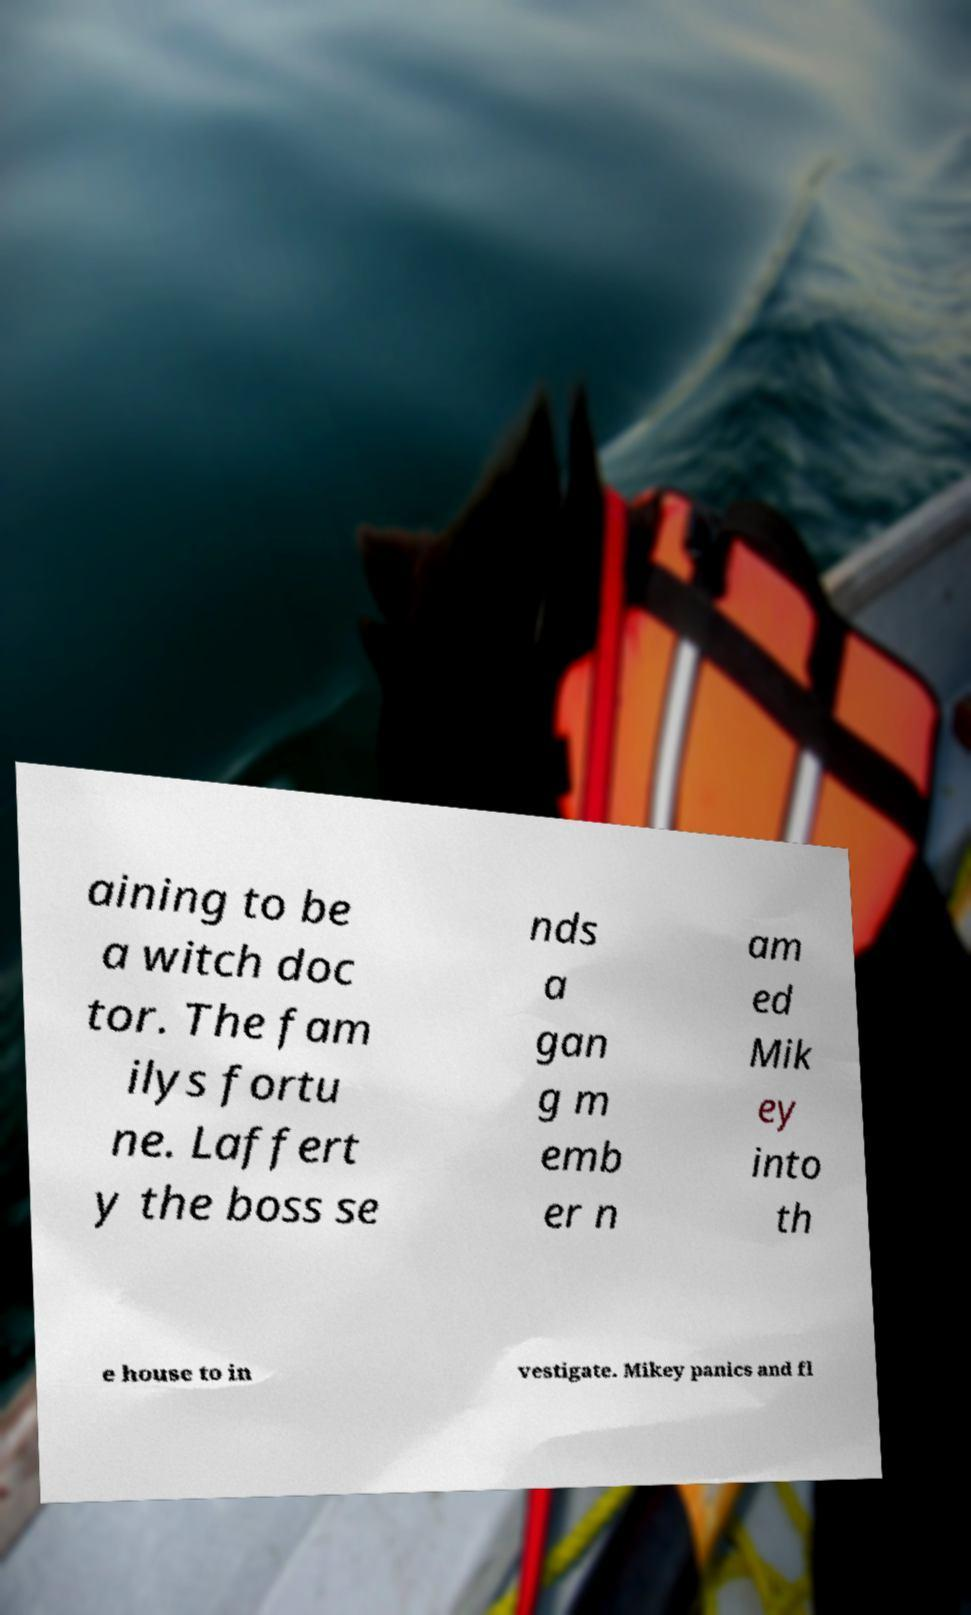Please read and relay the text visible in this image. What does it say? aining to be a witch doc tor. The fam ilys fortu ne. Laffert y the boss se nds a gan g m emb er n am ed Mik ey into th e house to in vestigate. Mikey panics and fl 